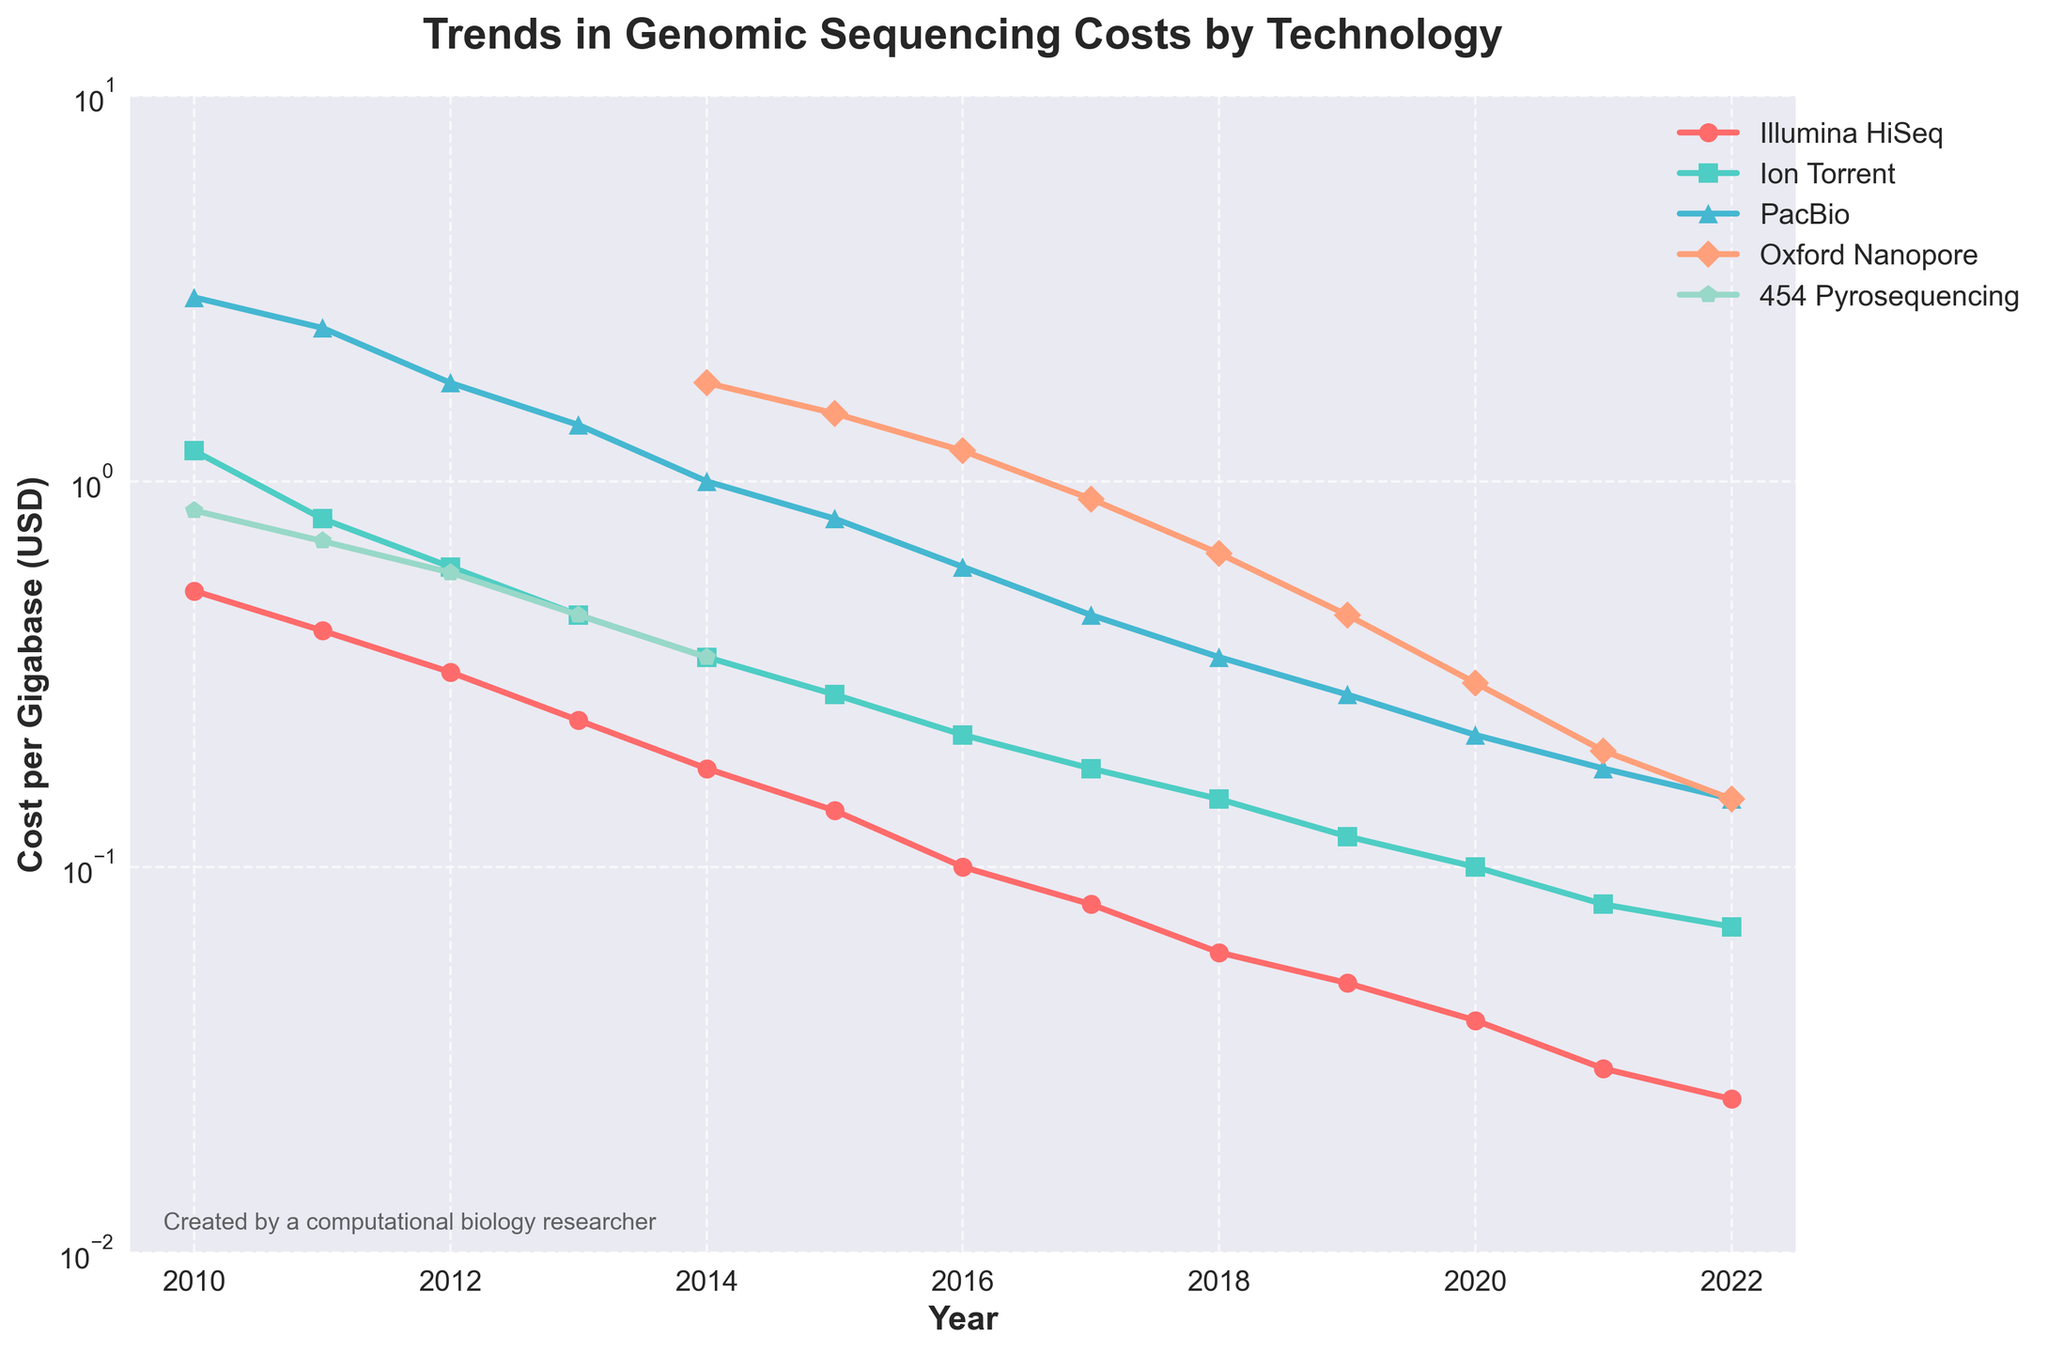What sequencing technology had the highest cost in 2010? Observing the data points for the year 2010, the PacBio technology had the highest cost per gigabase.
Answer: PacBio Which sequencing technology showed the fastest decline in costs between 2010 and 2022? Comparing the cost reduction in each technology from 2010 to 2022, Illumina HiSeq went from 0.52 to 0.025, representing the fastest decline.
Answer: Illumina HiSeq What was the cost per gigabase for Oxford Nanopore in 2014 and how does it compare to its cost in 2022? Oxford Nanopore's cost in 2014 was 1.80 USD, and by 2022, it had dropped to 0.15 USD, indicating a significant reduction.
Answer: Decreased from 1.80 to 0.15 Which technology had the lowest cost in 2022? In 2022, Illumina HiSeq had the lowest cost per gigabase among the technologies listed.
Answer: Illumina HiSeq Describe the trend for 454 Pyrosequencing technology over the years provided. 454 Pyrosequencing shows a steady decline in costs from 2010 (0.84 USD) until 2015, after which data is not available, indicating it might have been phased out.
Answer: Steady decline until 2015 Between 2010 and 2022, how many technologies showed a cost reduction of more than 1 USD per gigabase? Analyzing the data, Illumina HiSeq, Ion Torrent, PacBio, and 454 Pyrosequencing all showed cost reductions of more than 1 USD per gigabase over the specified period.
Answer: Four technologies Which technology had costs that fell below 0.10 USD per gigabase first, and in what year? Illumina HiSeq had costs that fell below 0.10 USD per gigabase first in the year 2016.
Answer: Illumina HiSeq in 2016 Compare the costs of Ion Torrent and PacBio in 2020. How much more expensive was PacBio? In 2020, Ion Torrent cost 0.10 USD per gigabase, and PacBio cost 0.22 USD per gigabase. PacBio was 0.12 USD more expensive than Ion Torrent.
Answer: 0.12 USD What was the approximate average cost reduction per year for Illumina HiSeq from 2010 to 2022? Illumina HiSeq cost reduced from 0.52 USD in 2010 to 0.025 USD in 2022. The total reduction is 0.495 USD over 12 years, so the average annual reduction is approximately 0.0413 USD.
Answer: 0.0413 USD per year 